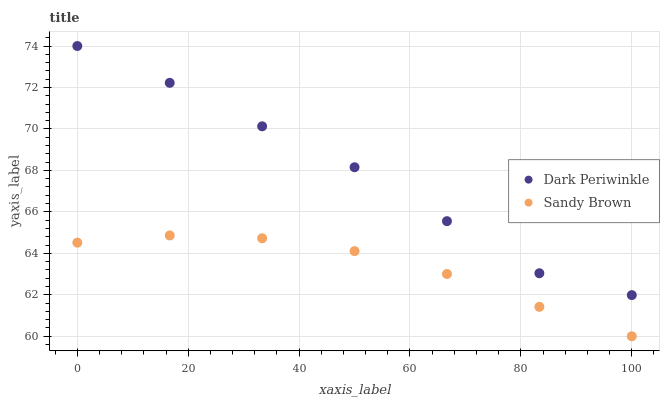Does Sandy Brown have the minimum area under the curve?
Answer yes or no. Yes. Does Dark Periwinkle have the maximum area under the curve?
Answer yes or no. Yes. Does Dark Periwinkle have the minimum area under the curve?
Answer yes or no. No. Is Sandy Brown the smoothest?
Answer yes or no. Yes. Is Dark Periwinkle the roughest?
Answer yes or no. Yes. Is Dark Periwinkle the smoothest?
Answer yes or no. No. Does Sandy Brown have the lowest value?
Answer yes or no. Yes. Does Dark Periwinkle have the lowest value?
Answer yes or no. No. Does Dark Periwinkle have the highest value?
Answer yes or no. Yes. Is Sandy Brown less than Dark Periwinkle?
Answer yes or no. Yes. Is Dark Periwinkle greater than Sandy Brown?
Answer yes or no. Yes. Does Sandy Brown intersect Dark Periwinkle?
Answer yes or no. No. 